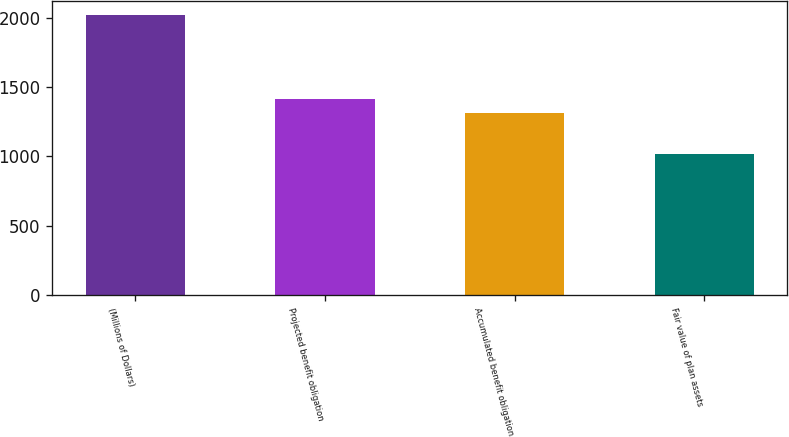Convert chart to OTSL. <chart><loc_0><loc_0><loc_500><loc_500><bar_chart><fcel>(Millions of Dollars)<fcel>Projected benefit obligation<fcel>Accumulated benefit obligation<fcel>Fair value of plan assets<nl><fcel>2016<fcel>1413.36<fcel>1313.2<fcel>1014.4<nl></chart> 